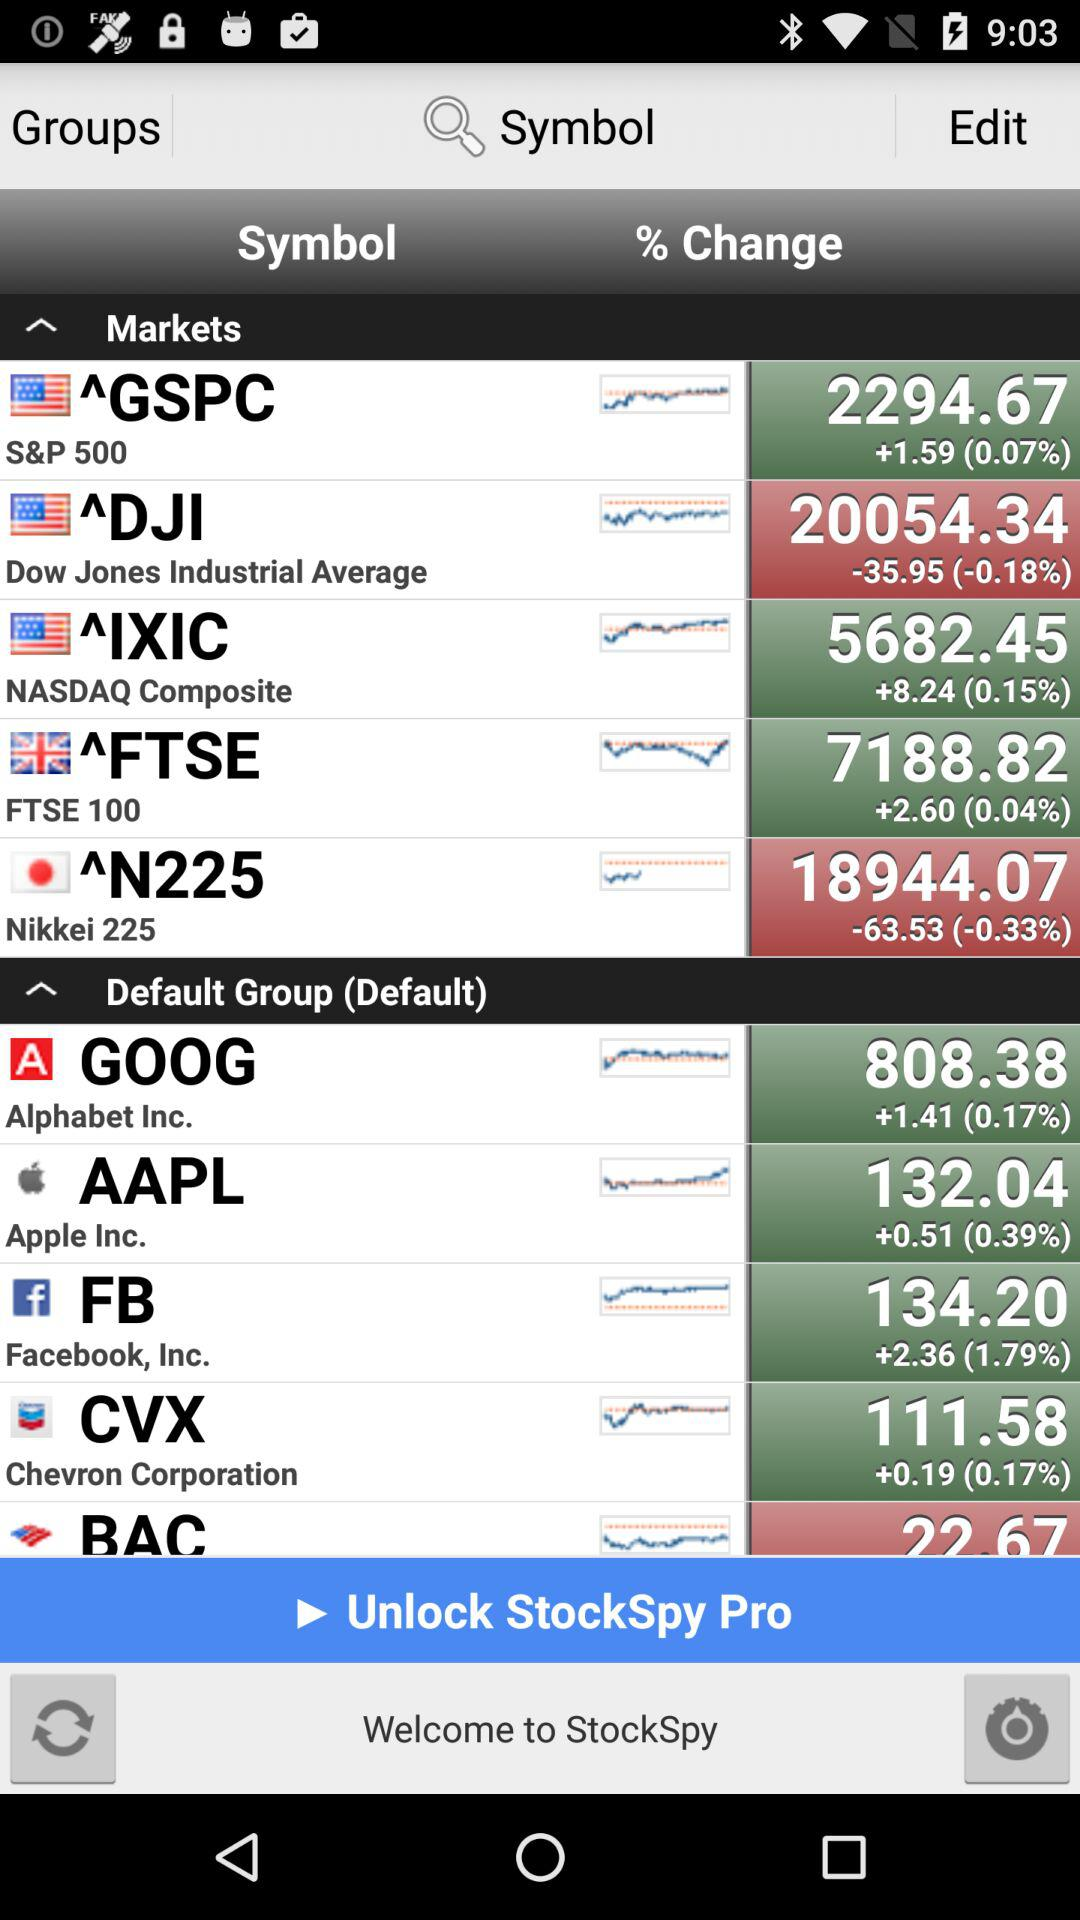How much did the DJI open at yesterday?
When the provided information is insufficient, respond with <no answer>. <no answer> 